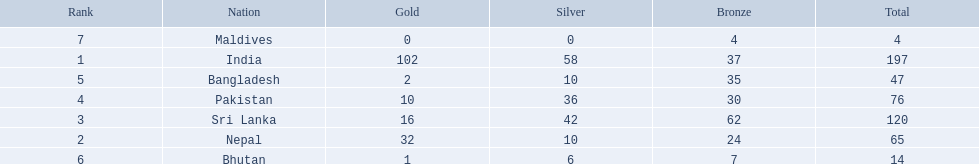Could you parse the entire table? {'header': ['Rank', 'Nation', 'Gold', 'Silver', 'Bronze', 'Total'], 'rows': [['7', 'Maldives', '0', '0', '4', '4'], ['1', 'India', '102', '58', '37', '197'], ['5', 'Bangladesh', '2', '10', '35', '47'], ['4', 'Pakistan', '10', '36', '30', '76'], ['3', 'Sri Lanka', '16', '42', '62', '120'], ['2', 'Nepal', '32', '10', '24', '65'], ['6', 'Bhutan', '1', '6', '7', '14']]} How many gold medals were won by the teams? 102, 32, 16, 10, 2, 1, 0. What country won no gold medals? Maldives. 